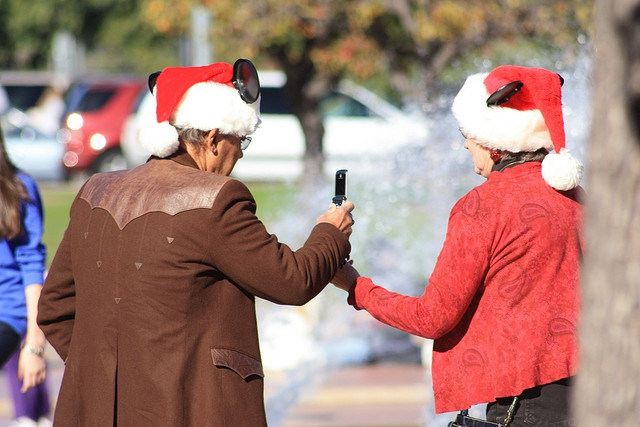Describe the objects in this image and their specific colors. I can see people in darkgreen, brown, maroon, and white tones, people in darkgreen, salmon, white, red, and black tones, car in darkgreen, white, darkgray, black, and teal tones, people in darkgreen, lightblue, blue, black, and ivory tones, and car in darkgreen, salmon, brown, white, and lightpink tones in this image. 